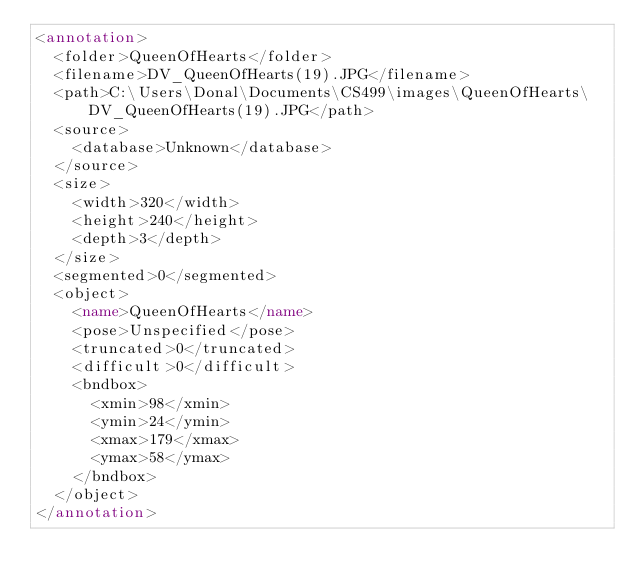Convert code to text. <code><loc_0><loc_0><loc_500><loc_500><_XML_><annotation>
	<folder>QueenOfHearts</folder>
	<filename>DV_QueenOfHearts(19).JPG</filename>
	<path>C:\Users\Donal\Documents\CS499\images\QueenOfHearts\DV_QueenOfHearts(19).JPG</path>
	<source>
		<database>Unknown</database>
	</source>
	<size>
		<width>320</width>
		<height>240</height>
		<depth>3</depth>
	</size>
	<segmented>0</segmented>
	<object>
		<name>QueenOfHearts</name>
		<pose>Unspecified</pose>
		<truncated>0</truncated>
		<difficult>0</difficult>
		<bndbox>
			<xmin>98</xmin>
			<ymin>24</ymin>
			<xmax>179</xmax>
			<ymax>58</ymax>
		</bndbox>
	</object>
</annotation>
</code> 